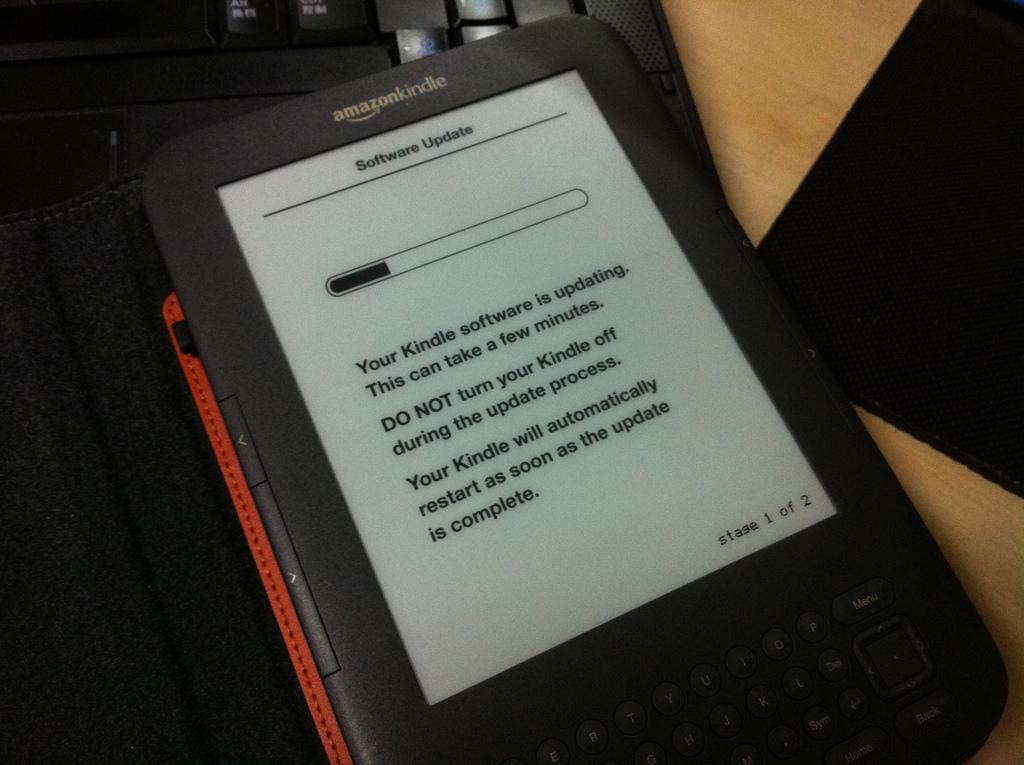Could you give a brief overview of what you see in this image? In this picture we can see a tablet and a keyboard. This keyboard is on a wooden table. 